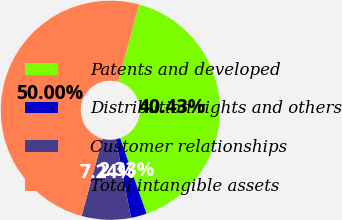Convert chart to OTSL. <chart><loc_0><loc_0><loc_500><loc_500><pie_chart><fcel>Patents and developed<fcel>Distribution rights and others<fcel>Customer relationships<fcel>Total intangible assets<nl><fcel>40.43%<fcel>2.33%<fcel>7.24%<fcel>50.0%<nl></chart> 